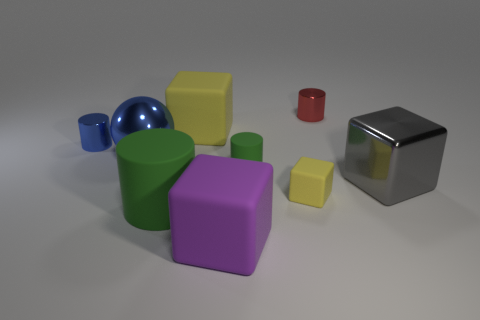What color is the cube that is behind the big gray shiny block on the right side of the small metal cylinder that is left of the large purple matte block?
Make the answer very short. Yellow. Do the metallic ball and the red object have the same size?
Offer a very short reply. No. What number of purple objects have the same size as the blue ball?
Offer a very short reply. 1. There is a metal thing that is the same color as the shiny sphere; what is its shape?
Your response must be concise. Cylinder. Is the material of the yellow thing that is behind the shiny sphere the same as the yellow cube that is in front of the tiny green rubber object?
Your answer should be very brief. Yes. Are there any other things that are the same shape as the large yellow object?
Your answer should be very brief. Yes. The big cylinder is what color?
Offer a very short reply. Green. What number of large matte things have the same shape as the small blue thing?
Offer a very short reply. 1. What color is the metal cube that is the same size as the blue ball?
Provide a short and direct response. Gray. Are there any blue cubes?
Your response must be concise. No. 